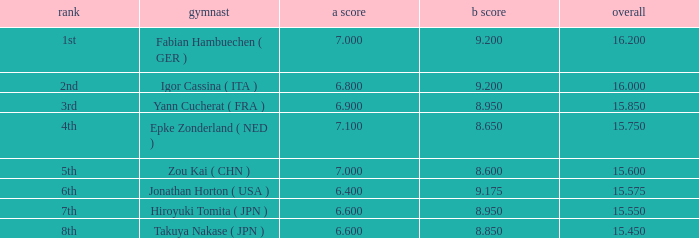What was the total rating that had a score higher than 7 and a b score smaller than 8.65? None. 